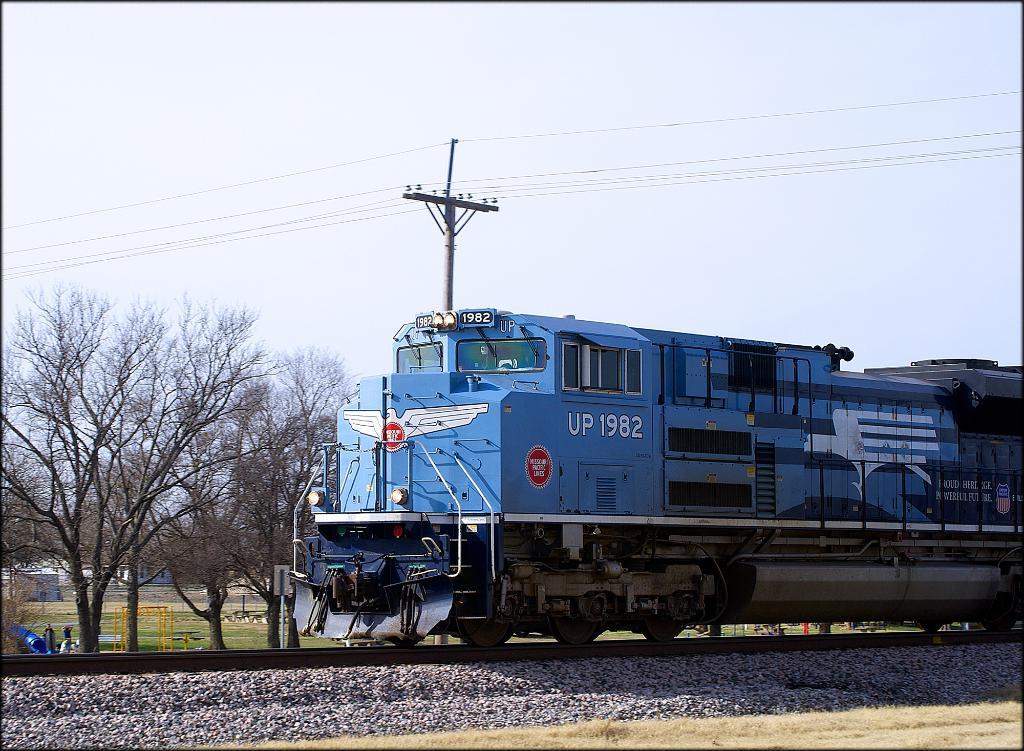What is the number on the locomotive?
Give a very brief answer. 1982. What word is written next to the train number?
Provide a succinct answer. Up. 